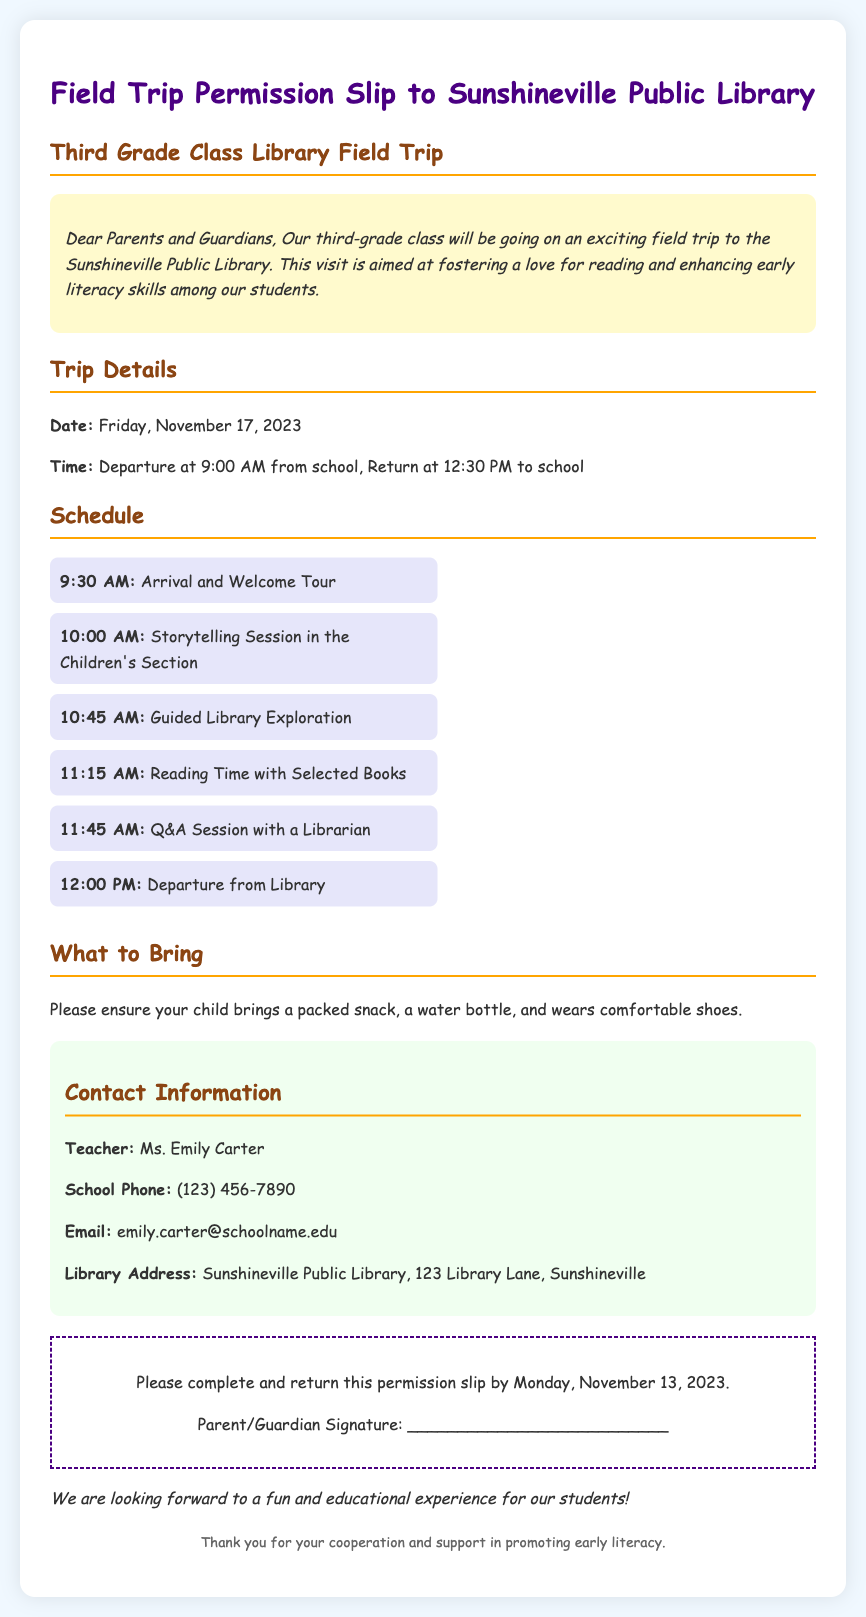What is the date of the field trip? The date is specified in the "Trip Details" section of the document.
Answer: Friday, November 17, 2023 What time does the trip depart from school? The departure time is mentioned in the "Trip Details" section.
Answer: 9:00 AM Who is the teacher organizing the trip? The teacher's name is provided in the "Contact Information" section.
Answer: Ms. Emily Carter What activity takes place at 10:00 AM? The schedule lists activities with their corresponding times.
Answer: Storytelling Session in the Children's Section What should students bring for the trip? The document includes instructions on what to bring in the "What to Bring" section.
Answer: Packed snack, water bottle, comfortable shoes When is the permission slip due? The due date for the permission slip is indicated in the "permission" section.
Answer: Monday, November 13, 2023 What is the address of the library? The library address is provided in the "Contact Information" section.
Answer: 123 Library Lane, Sunshineville What is the purpose of the field trip? The introduction mentions the overarching goal for the students.
Answer: Foster a love for reading and enhance early literacy skills How long will the trip last? The duration of the trip can be calculated from the departure and return times mentioned in the "Trip Details."
Answer: 3.5 hours 